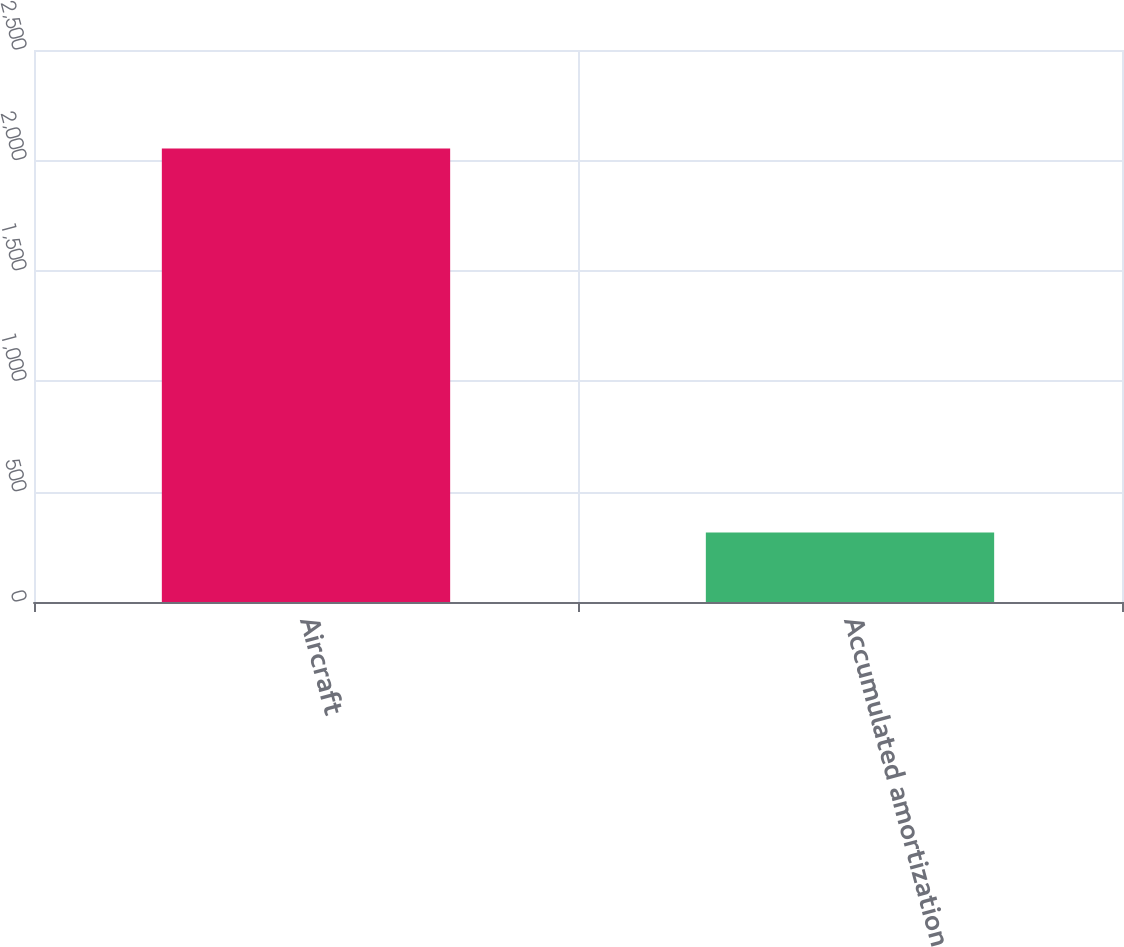Convert chart to OTSL. <chart><loc_0><loc_0><loc_500><loc_500><bar_chart><fcel>Aircraft<fcel>Accumulated amortization<nl><fcel>2054<fcel>315<nl></chart> 